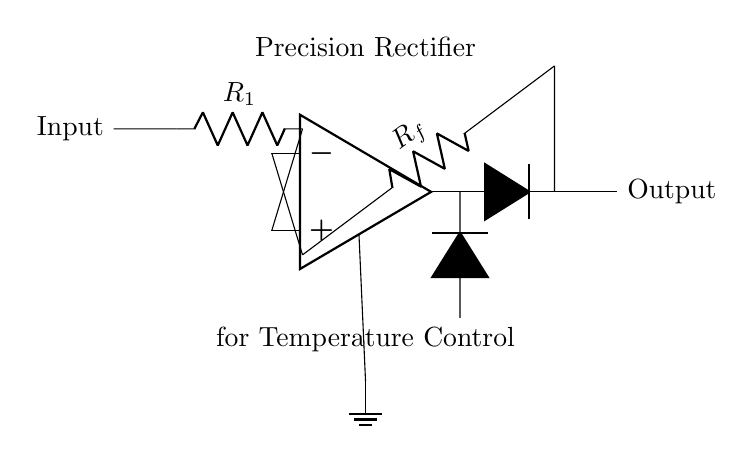What type of amplifier is used in this circuit? The circuit includes an operational amplifier depicted at the left side, indicating that this is a precision rectifier circuit. The symbol specifically represents an op-amp, which operates under the principles of feedback and can amplify small voltage signals.
Answer: operational amplifier What is the role of the diodes in this circuit? The diodes serve as rectifying components that allow current to flow in one direction only. In this precision rectifier configuration, they enable the circuit to convert both positive and negative input voltages to a positive output voltage, thus facilitating precise control of temperature in food preparation equipment.
Answer: rectification What are the values of the resistors in the circuit? The circuit diagram labels the resistors as R1 and Rf, without providing specific numerical values. R1 is in the input path while Rf is part of the feedback loop from the output to the inverting input of the op-amp. The resistance values determine the gain and input characteristics for the precise rectification.
Answer: R1 and Rf How does the feedback loop affect the circuit operation? The feedback loop connects the output of the op-amp back to its inverting input, which stabilizes the circuit's performance. It ensures that the output voltage closely follows the input voltage, allowing for improved accuracy in the rectification process, thereby playing a crucial role in maintaining the correct temperature for food preparation.
Answer: stabilizes performance What is the expected output of this precision rectifier circuit? The expected output would be a smooth, rectified voltage that closely corresponds to the magnitude of the input voltage, with any negative values flipped to positive. This output can be measured in volts and will be used for precise temperature control in gourmet food preparation equipment.
Answer: smooth rectified voltage What is the significance of the ground connection in this circuit? The ground connection is essential as it serves as a common reference point for all voltage measurements within the circuit. It helps to stabilize the potential differences across components, ensuring accurate operation of the op-amp and the entire precision rectifier circuit for effective temperature control.
Answer: common reference point 